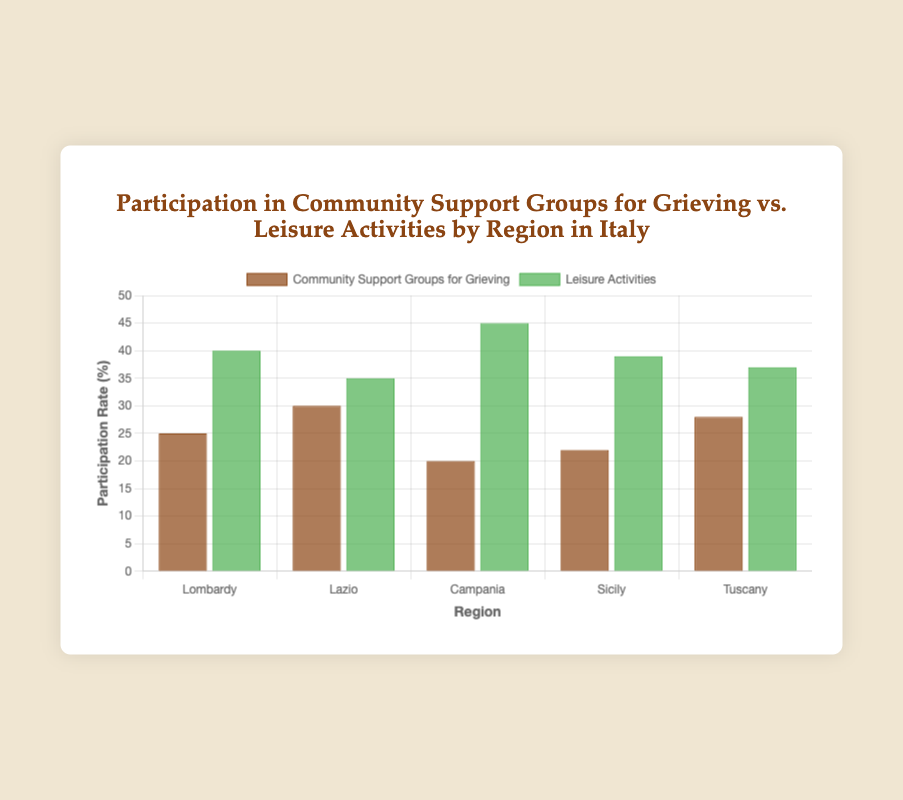What is the participation rate in Leisure Activities in Tuscany? Look at the data for Leisure Activities in the Tuscany region, which is represented by the green bar. The figure shows that the bar reaches 37%.
Answer: 37% Which region has the highest participation in Community Support Groups for Grieving? Compare the heights of the brown bars representing Community Support Groups for Grieving across all regions. The highest bar is in Lazio at 30%.
Answer: Lazio What is the difference in participation rates between Community Support Groups for Grieving and Leisure Activities in Lombardy? From the figure, the participation rates are 25% for Community Support Groups for Grieving and 40% for Leisure Activities in Lombardy. The difference is 40% - 25% = 15%.
Answer: 15% How many regions have a higher participation rate in Leisure Activities than in Community Support Groups for Grieving? By comparing the green and brown bars for each region, all regions (Lombardy, Lazio, Campania, Sicily, and Tuscany) have a higher participation in Leisure Activities than in Community Support Groups for Grieving. Hence, the number is 5.
Answer: 5 What is the average participation rate in Community Support Groups for Grieving across all regions? Sum the participation rates for Community Support Groups for Grieving: 25% + 30% + 20% + 22% + 28% = 125%. Then, divide by the number of regions, 125% / 5 = 25%.
Answer: 25% Which has a higher average participation rate, Community Support Groups for Grieving or Leisure Activities? Calculate the average participation rate for each activity. For Community Support Groups for Grieving: (25% + 30% + 20% + 22% + 28%) / 5 = 25%. For Leisure Activities: (40% + 35% + 45% + 39% + 37%) / 5 = 39.2%. Comparing the averages, 39.2% is higher than 25%.
Answer: Leisure Activities In which region is the gap between participation rates in Community Support Groups for Grieving and Leisure Activities the greatest? Calculate the gaps for each region: Lombardy: 40% - 25% = 15%, Lazio: 35% - 30% = 5%, Campania: 45% - 20% = 25%, Sicily: 39% - 22% = 17%, Tuscany: 37% - 28% = 9%. The greatest gap is in Campania at 25%.
Answer: Campania 